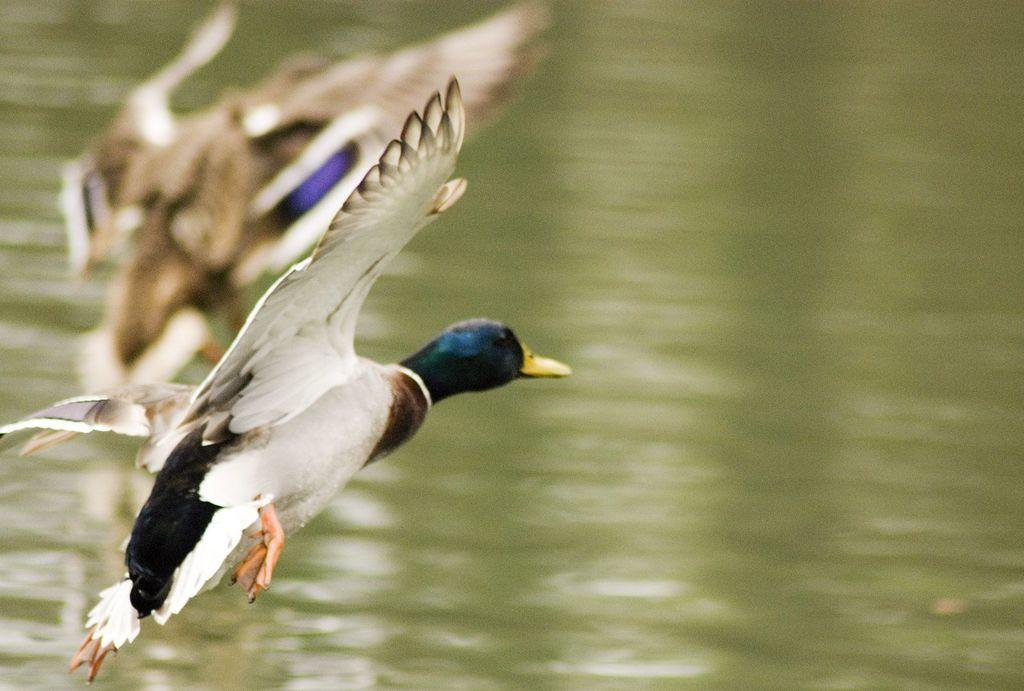What type of animals can be seen in the image? Birds can be seen in the image. What is the primary element in which the birds are situated? The birds are situated in water. What can be seen in the background of the image? There is water visible in the background of the image. What reason does the bird have for hating the water in the image? There is no indication in the image that the bird hates the water, nor is there any reason provided for such a feeling. 